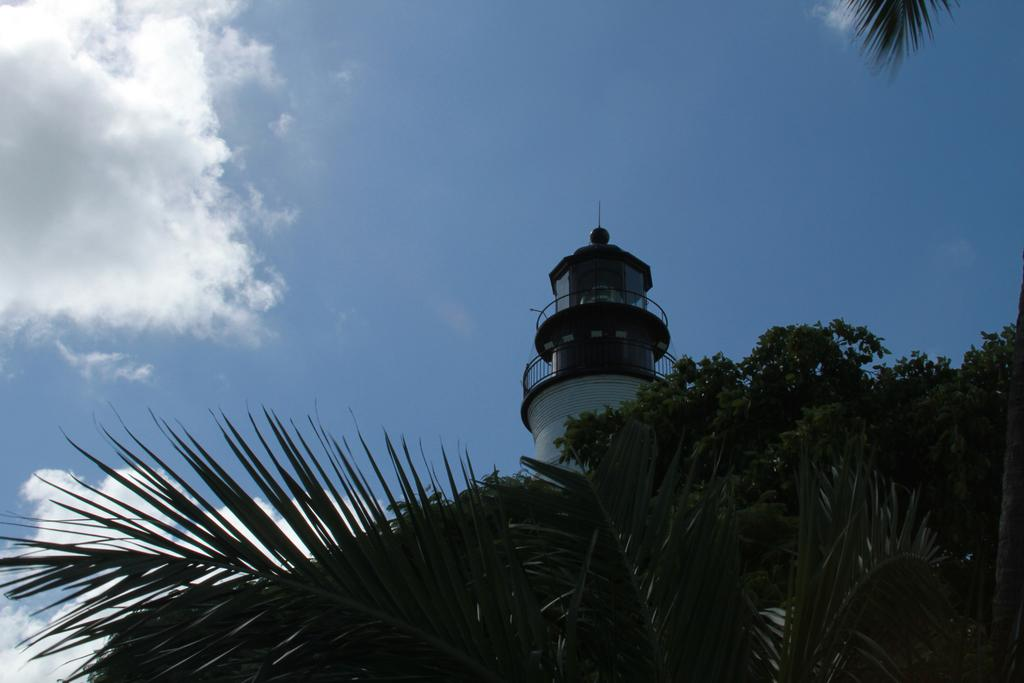What type of vegetation can be seen in the image? There are trees in the image. What structure is present in the image? There is a tower in the image. What is visible at the top of the image? The sky is visible in the image. What can be seen in the sky in the image? There are clouds in the sky. Where is the view of the stage in the image? There is no view of a stage present in the image. How many spiders can be seen crawling on the trees in the image? There are no spiders visible in the image. 